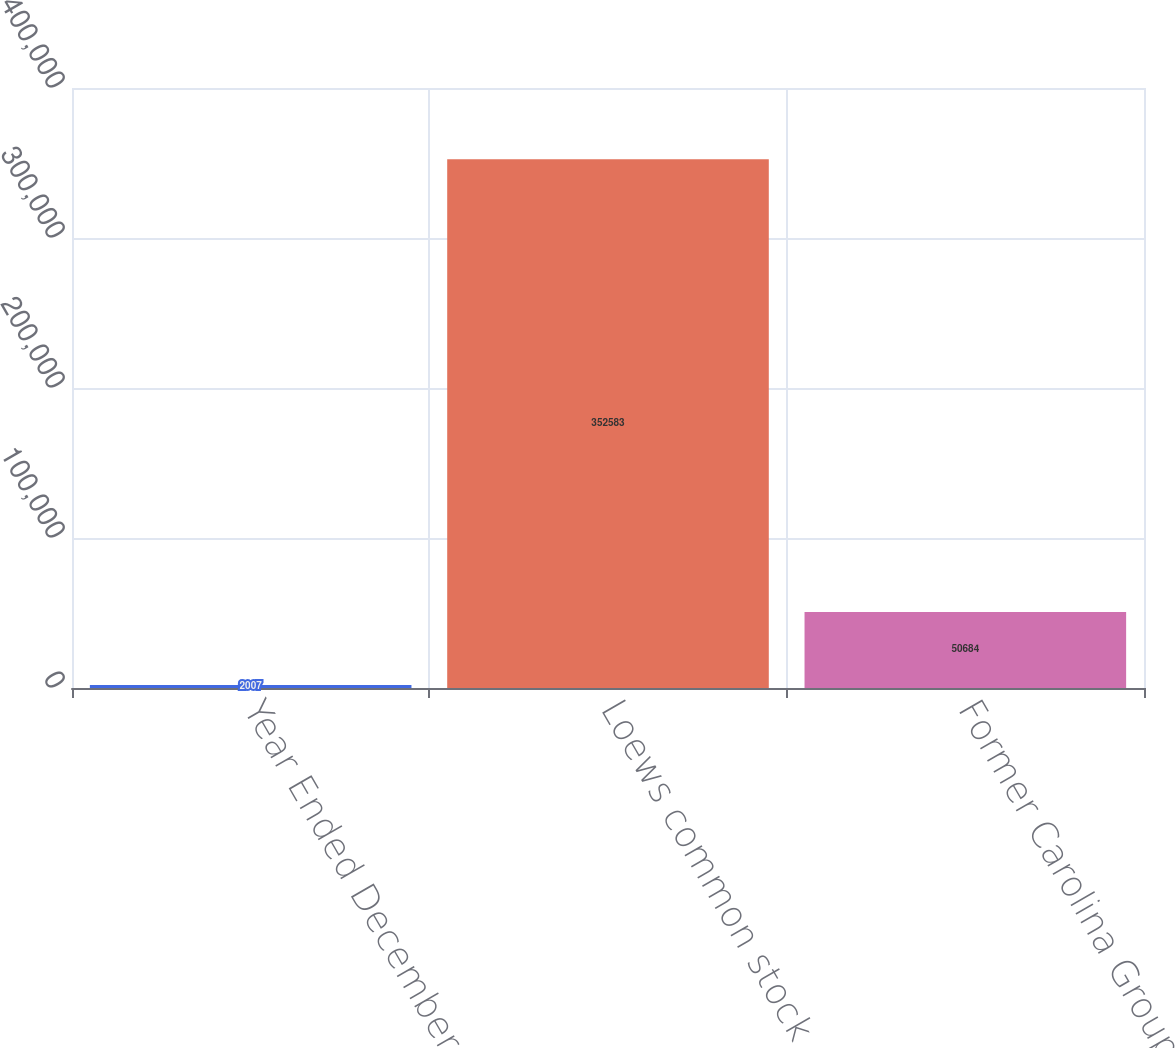<chart> <loc_0><loc_0><loc_500><loc_500><bar_chart><fcel>Year Ended December 31<fcel>Loews common stock<fcel>Former Carolina Group stock<nl><fcel>2007<fcel>352583<fcel>50684<nl></chart> 